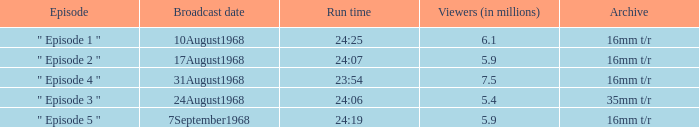How many episodes in history have a running time of 24:06? 1.0. 